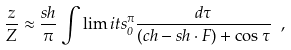<formula> <loc_0><loc_0><loc_500><loc_500>\frac { z } { Z } \approx \frac { s h } { \pi } \int \lim i t s _ { 0 } ^ { \pi } \frac { d \tau } { ( c h - s h \cdot F ) + \cos { \tau } } \ ,</formula> 